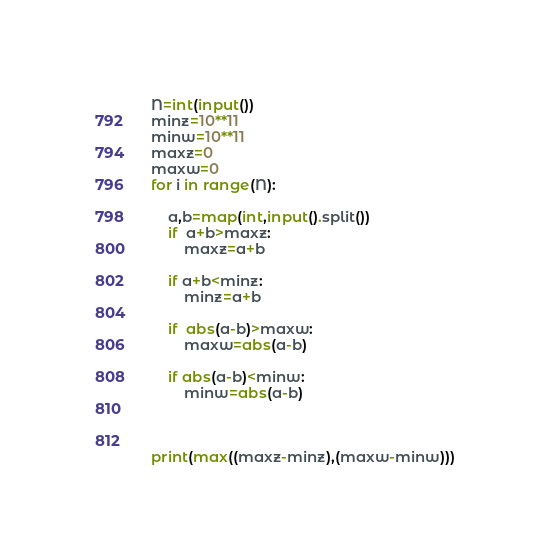Convert code to text. <code><loc_0><loc_0><loc_500><loc_500><_Python_>N=int(input())
minz=10**11
minw=10**11
maxz=0
maxw=0
for i in range(N):
 
    a,b=map(int,input().split())
    if  a+b>maxz:
        maxz=a+b

    if a+b<minz:
        minz=a+b

    if  abs(a-b)>maxw:
        maxw=abs(a-b)

    if abs(a-b)<minw:
        minw=abs(a-b)

    
 
print(max((maxz-minz),(maxw-minw)))</code> 